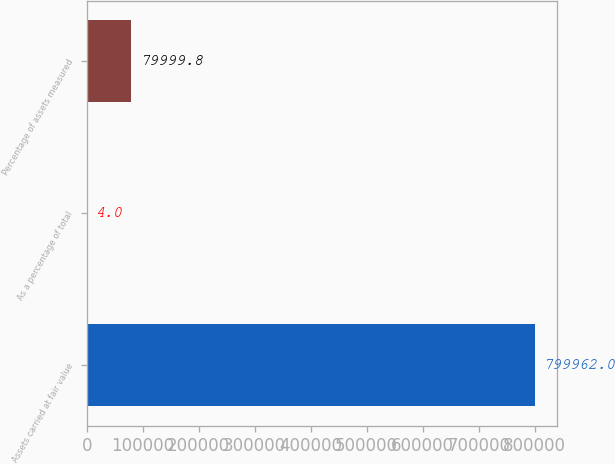Convert chart. <chart><loc_0><loc_0><loc_500><loc_500><bar_chart><fcel>Assets carried at fair value<fcel>As a percentage of total<fcel>Percentage of assets measured<nl><fcel>799962<fcel>4<fcel>79999.8<nl></chart> 